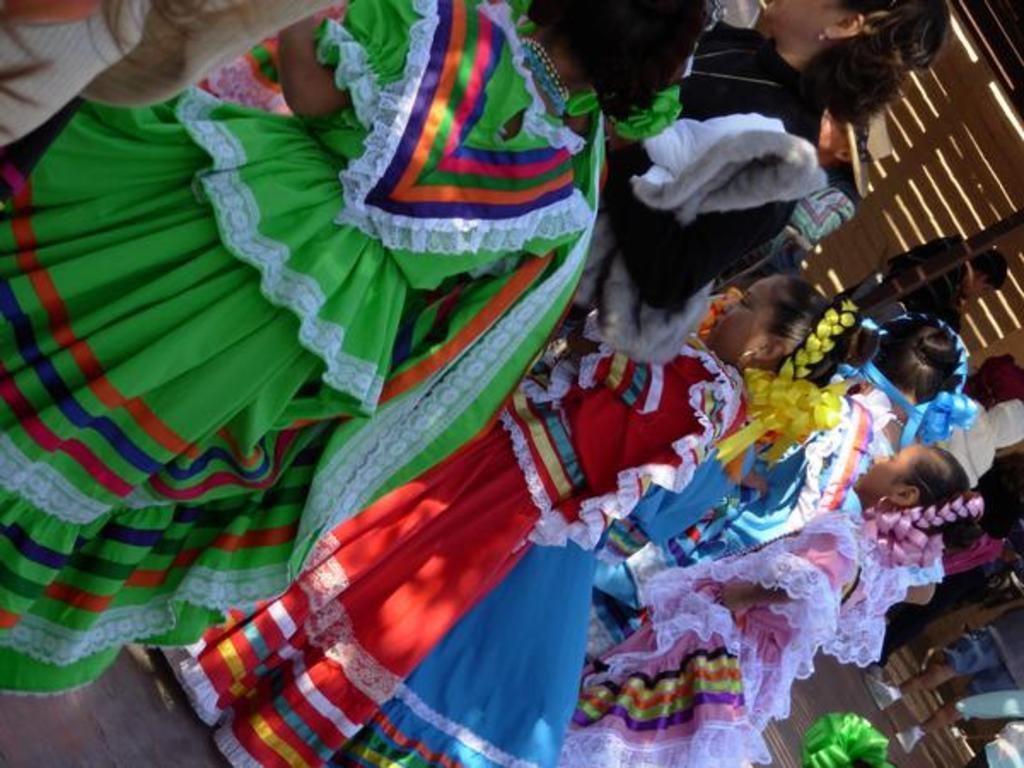Could you give a brief overview of what you see in this image? In the middle of the image few persons are standing. Bottom right side of the image few people are walking. Top right side of the image there is a wall. 